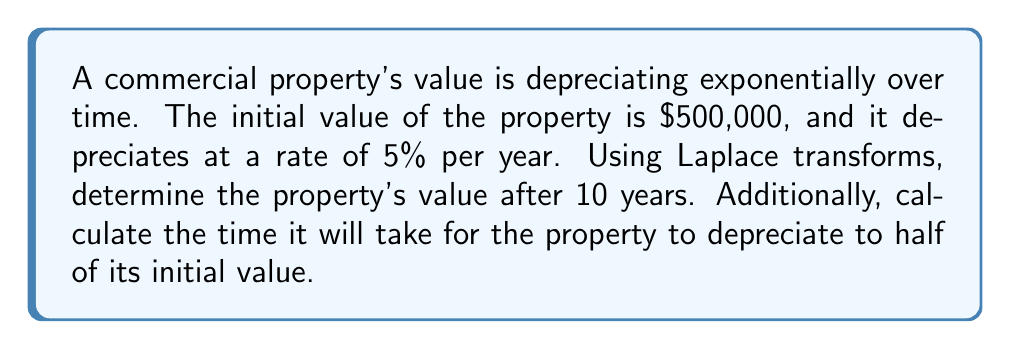Show me your answer to this math problem. Let's approach this problem step-by-step using Laplace transforms:

1) Let $V(t)$ represent the property value at time $t$ (in years). The depreciation can be modeled by the equation:

   $$V(t) = 500000 \cdot e^{-0.05t}$$

2) To find the value after 10 years, we could simply plug in $t=10$. However, let's use Laplace transforms to practice.

3) The Laplace transform of $V(t)$ is:

   $$\mathcal{L}\{V(t)\} = \int_0^\infty 500000 \cdot e^{-0.05t} \cdot e^{-st} dt = \frac{500000}{s+0.05}$$

4) To find the value at $t=10$, we need to use the inverse Laplace transform and the shifting theorem:

   $$V(10) = \mathcal{L}^{-1}\{e^{-10s} \cdot \frac{500000}{s+0.05}\}$$

5) Applying the inverse transform:

   $$V(10) = 500000 \cdot e^{-0.05 \cdot 10} \approx 303265$$

6) For the second part, we need to find $t$ when $V(t) = 250000$ (half of the initial value).

7) Using the original equation:

   $$250000 = 500000 \cdot e^{-0.05t}$$

8) Taking natural logarithm of both sides:

   $$\ln(0.5) = -0.05t$$

9) Solving for $t$:

   $$t = -\frac{\ln(0.5)}{0.05} \approx 13.86$$
Answer: The property's value after 10 years is approximately $303,265. It will take approximately 13.86 years for the property to depreciate to half of its initial value. 